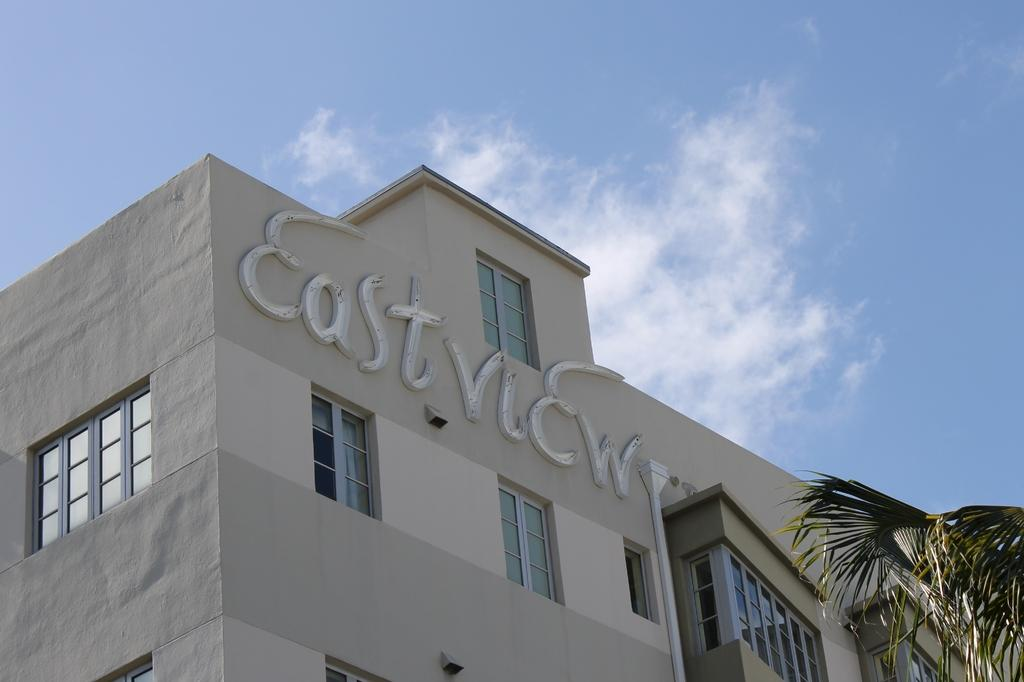What structure is the main subject of the image? There is a building in the image. What type of vegetation is on the right side of the image? There is a tree on the right side of the image. What is the condition of the sky in the image? The sky is cloudy in the image. What type of smell can be detected from the dock in the image? There is no dock present in the image, so it is not possible to determine any associated smells. 